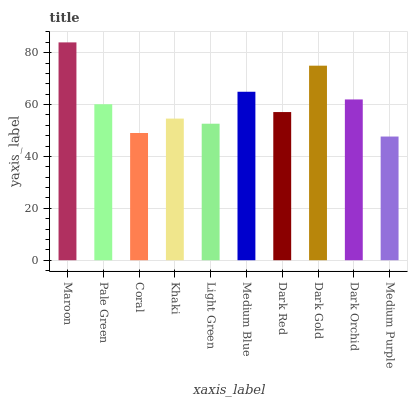Is Medium Purple the minimum?
Answer yes or no. Yes. Is Maroon the maximum?
Answer yes or no. Yes. Is Pale Green the minimum?
Answer yes or no. No. Is Pale Green the maximum?
Answer yes or no. No. Is Maroon greater than Pale Green?
Answer yes or no. Yes. Is Pale Green less than Maroon?
Answer yes or no. Yes. Is Pale Green greater than Maroon?
Answer yes or no. No. Is Maroon less than Pale Green?
Answer yes or no. No. Is Pale Green the high median?
Answer yes or no. Yes. Is Dark Red the low median?
Answer yes or no. Yes. Is Khaki the high median?
Answer yes or no. No. Is Coral the low median?
Answer yes or no. No. 